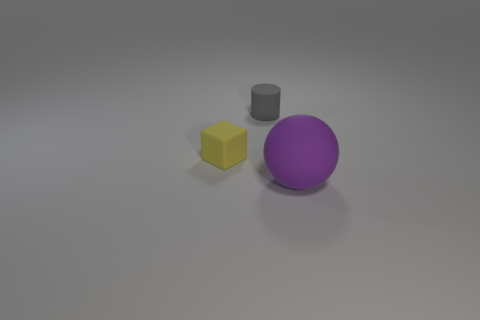Are there any other things that have the same size as the purple thing?
Offer a terse response. No. What material is the small thing that is in front of the tiny gray cylinder?
Offer a terse response. Rubber. Are there the same number of purple rubber balls that are in front of the purple sphere and big purple spheres behind the small yellow rubber object?
Give a very brief answer. Yes. Is there anything else that is the same color as the small block?
Make the answer very short. No. What number of metal things are red cylinders or purple balls?
Your response must be concise. 0. Does the cylinder have the same color as the rubber sphere?
Provide a short and direct response. No. Are there more objects to the left of the small gray rubber cylinder than gray rubber things?
Ensure brevity in your answer.  No. How many other objects are there of the same material as the purple ball?
Offer a terse response. 2. What number of big objects are either gray matte things or gray shiny cubes?
Make the answer very short. 0. Is the gray thing made of the same material as the sphere?
Offer a terse response. Yes. 